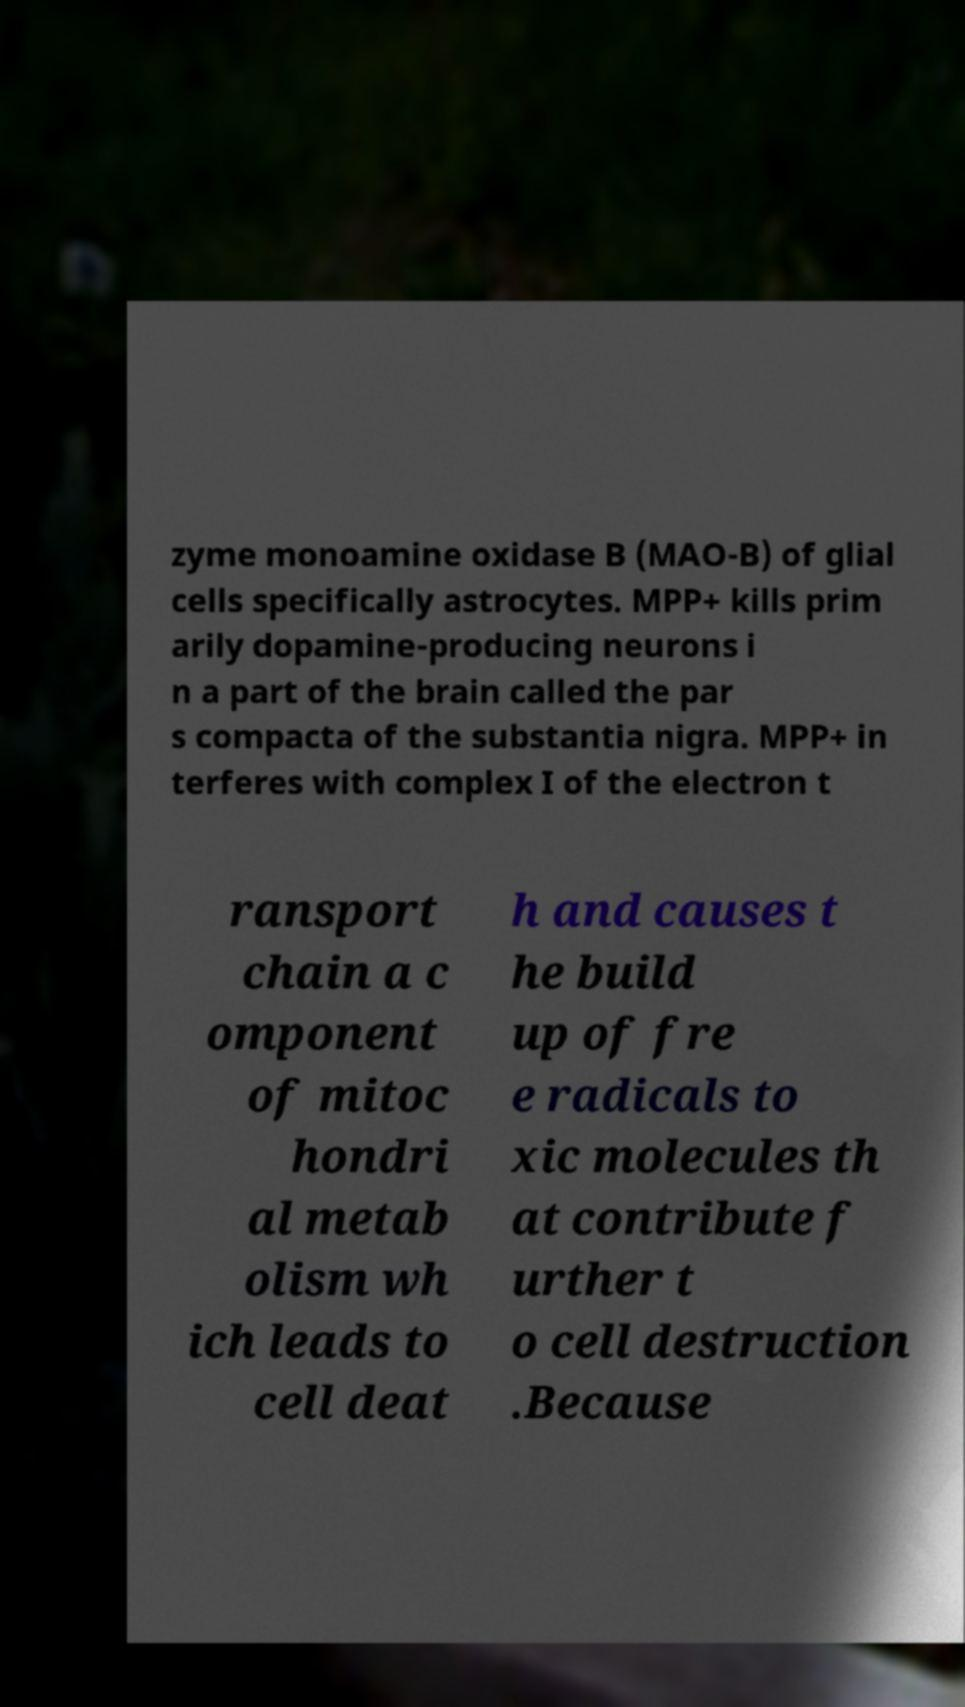There's text embedded in this image that I need extracted. Can you transcribe it verbatim? zyme monoamine oxidase B (MAO-B) of glial cells specifically astrocytes. MPP+ kills prim arily dopamine-producing neurons i n a part of the brain called the par s compacta of the substantia nigra. MPP+ in terferes with complex I of the electron t ransport chain a c omponent of mitoc hondri al metab olism wh ich leads to cell deat h and causes t he build up of fre e radicals to xic molecules th at contribute f urther t o cell destruction .Because 